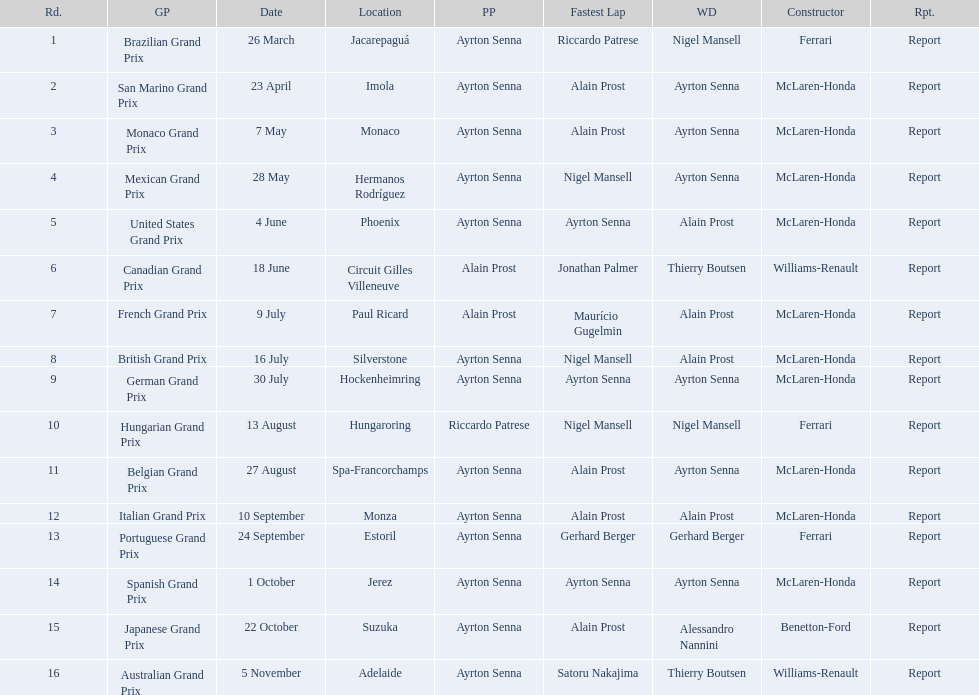Who are the constructors in the 1989 formula one season? Ferrari, McLaren-Honda, McLaren-Honda, McLaren-Honda, McLaren-Honda, Williams-Renault, McLaren-Honda, McLaren-Honda, McLaren-Honda, Ferrari, McLaren-Honda, McLaren-Honda, Ferrari, McLaren-Honda, Benetton-Ford, Williams-Renault. On what date was bennington ford the constructor? 22 October. What was the race on october 22? Japanese Grand Prix. 